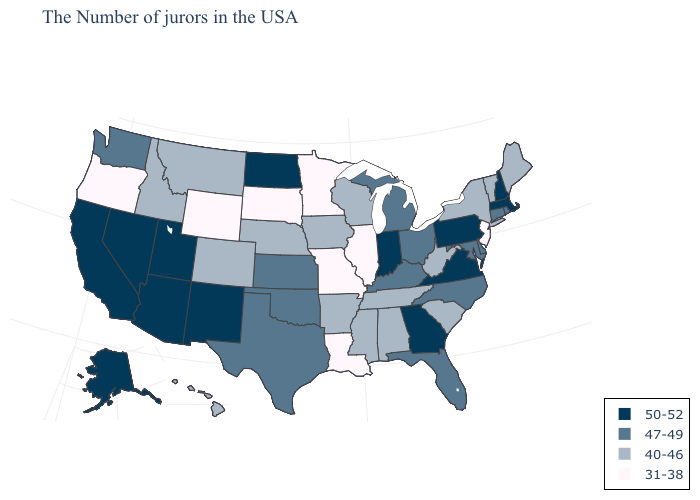Does Arkansas have a lower value than Vermont?
Quick response, please. No. What is the value of Alabama?
Answer briefly. 40-46. Among the states that border Mississippi , which have the lowest value?
Keep it brief. Louisiana. What is the highest value in states that border Mississippi?
Short answer required. 40-46. Name the states that have a value in the range 47-49?
Concise answer only. Rhode Island, Connecticut, Delaware, Maryland, North Carolina, Ohio, Florida, Michigan, Kentucky, Kansas, Oklahoma, Texas, Washington. Which states have the lowest value in the USA?
Concise answer only. New Jersey, Illinois, Louisiana, Missouri, Minnesota, South Dakota, Wyoming, Oregon. What is the value of Montana?
Quick response, please. 40-46. What is the value of New York?
Be succinct. 40-46. Does the first symbol in the legend represent the smallest category?
Concise answer only. No. Name the states that have a value in the range 47-49?
Write a very short answer. Rhode Island, Connecticut, Delaware, Maryland, North Carolina, Ohio, Florida, Michigan, Kentucky, Kansas, Oklahoma, Texas, Washington. Among the states that border New Jersey , does Delaware have the highest value?
Concise answer only. No. Does Pennsylvania have the highest value in the Northeast?
Answer briefly. Yes. What is the highest value in states that border New Jersey?
Give a very brief answer. 50-52. Does the map have missing data?
Write a very short answer. No. What is the highest value in the USA?
Give a very brief answer. 50-52. 